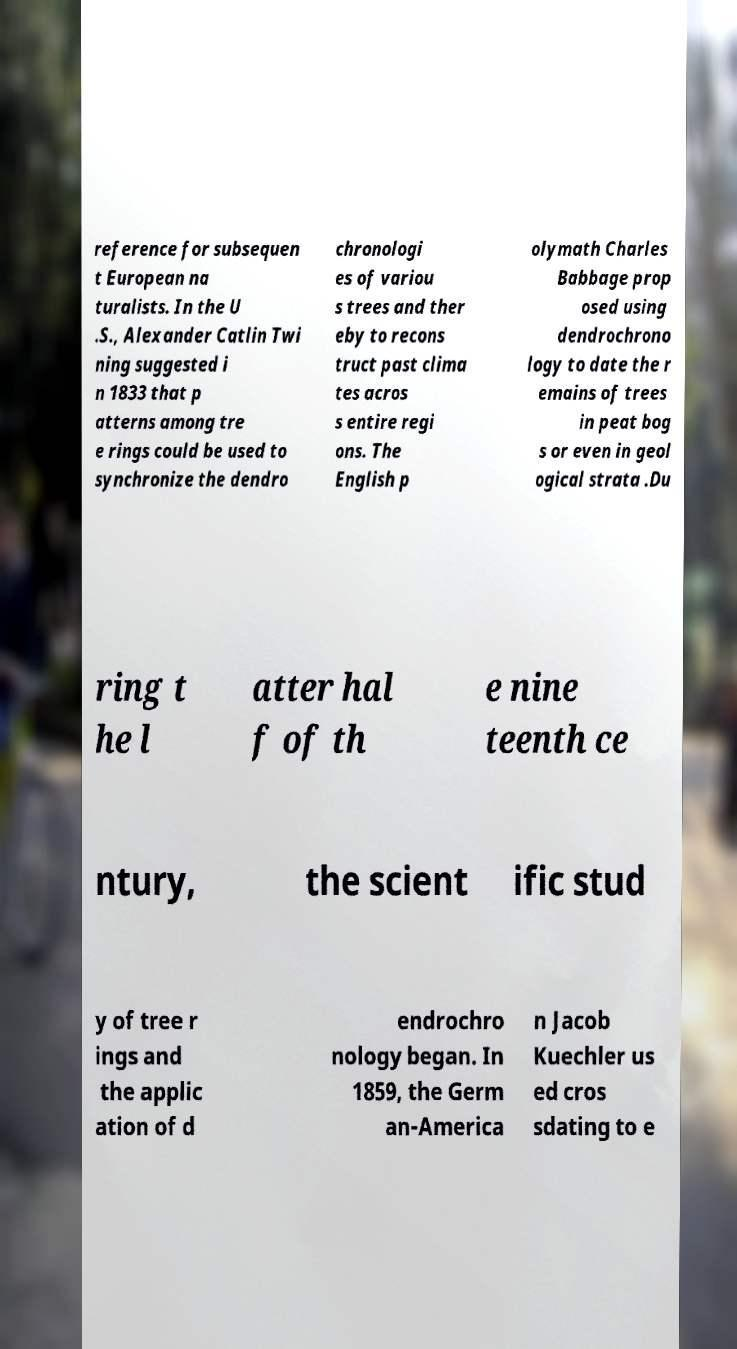Can you accurately transcribe the text from the provided image for me? reference for subsequen t European na turalists. In the U .S., Alexander Catlin Twi ning suggested i n 1833 that p atterns among tre e rings could be used to synchronize the dendro chronologi es of variou s trees and ther eby to recons truct past clima tes acros s entire regi ons. The English p olymath Charles Babbage prop osed using dendrochrono logy to date the r emains of trees in peat bog s or even in geol ogical strata .Du ring t he l atter hal f of th e nine teenth ce ntury, the scient ific stud y of tree r ings and the applic ation of d endrochro nology began. In 1859, the Germ an-America n Jacob Kuechler us ed cros sdating to e 